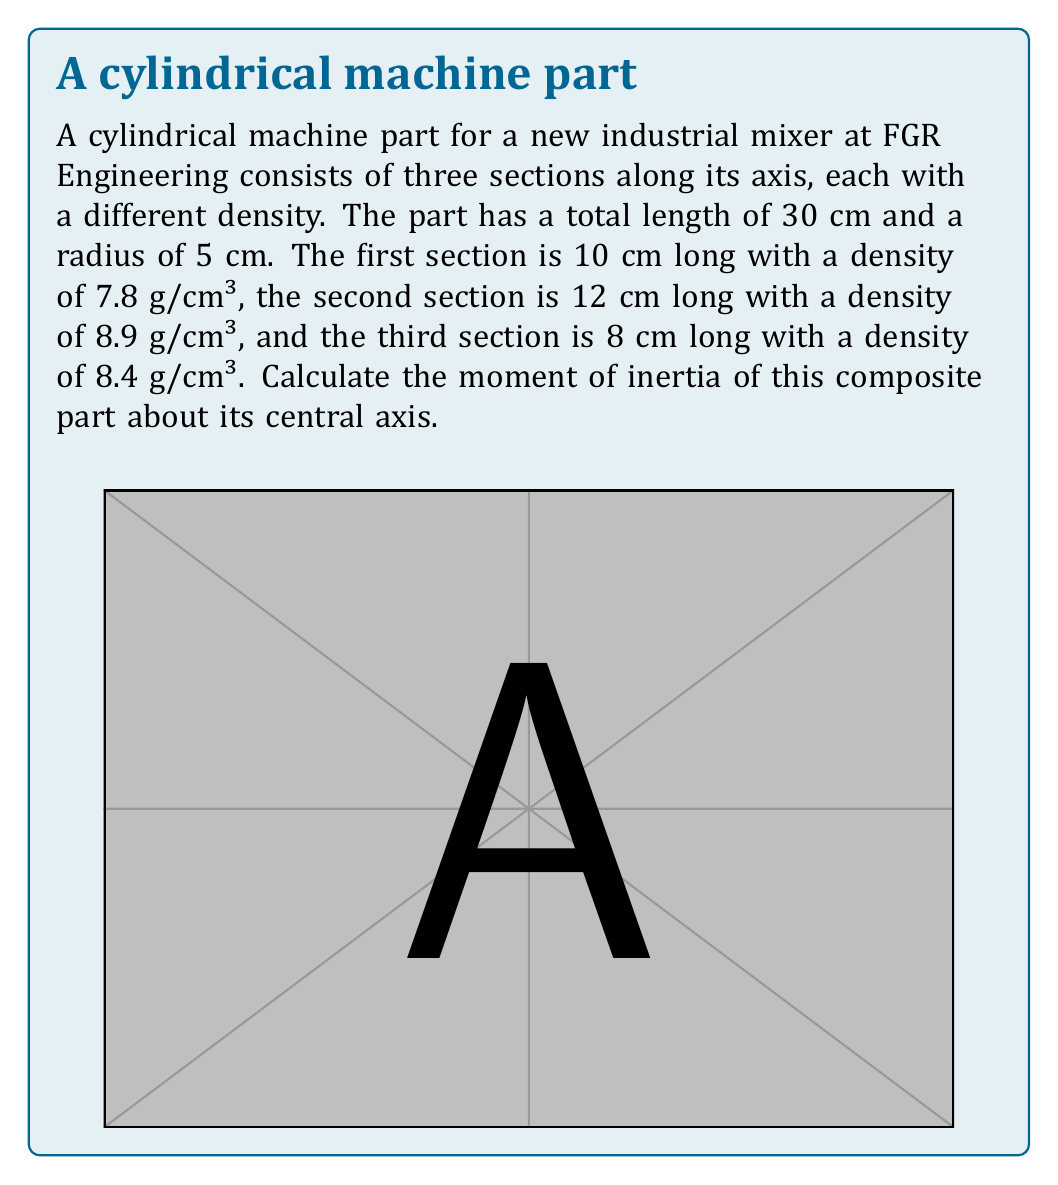Could you help me with this problem? To solve this problem, we need to calculate the moment of inertia for each section and then sum them up. The moment of inertia of a solid cylinder about its central axis is given by the formula:

$$I = \frac{1}{2}mr^2$$

where $m$ is the mass and $r$ is the radius.

Let's calculate the mass and moment of inertia for each section:

1. First section:
   Volume: $V_1 = \pi r^2 h_1 = \pi \cdot (5\text{ cm})^2 \cdot 10\text{ cm} = 785.4\text{ cm}^3$
   Mass: $m_1 = \rho_1 V_1 = 7.8\text{ g/cm}^3 \cdot 785.4\text{ cm}^3 = 6126.12\text{ g}$
   Moment of inertia: $I_1 = \frac{1}{2}m_1r^2 = \frac{1}{2} \cdot 6126.12\text{ g} \cdot (5\text{ cm})^2 = 76576.5\text{ g·cm}^2$

2. Second section:
   Volume: $V_2 = \pi r^2 h_2 = \pi \cdot (5\text{ cm})^2 \cdot 12\text{ cm} = 942.48\text{ cm}^3$
   Mass: $m_2 = \rho_2 V_2 = 8.9\text{ g/cm}^3 \cdot 942.48\text{ cm}^3 = 8388.072\text{ g}$
   Moment of inertia: $I_2 = \frac{1}{2}m_2r^2 = \frac{1}{2} \cdot 8388.072\text{ g} \cdot (5\text{ cm})^2 = 104850.9\text{ g·cm}^2$

3. Third section:
   Volume: $V_3 = \pi r^2 h_3 = \pi \cdot (5\text{ cm})^2 \cdot 8\text{ cm} = 628.32\text{ cm}^3$
   Mass: $m_3 = \rho_3 V_3 = 8.4\text{ g/cm}^3 \cdot 628.32\text{ cm}^3 = 5277.888\text{ g}$
   Moment of inertia: $I_3 = \frac{1}{2}m_3r^2 = \frac{1}{2} \cdot 5277.888\text{ g} \cdot (5\text{ cm})^2 = 65973.6\text{ g·cm}^2$

The total moment of inertia is the sum of the individual moments of inertia:

$$I_{\text{total}} = I_1 + I_2 + I_3 = 76576.5 + 104850.9 + 65973.6 = 247401\text{ g·cm}^2$$

Converting to kg·m²:
$$I_{\text{total}} = 247401\text{ g·cm}^2 \cdot \frac{1\text{ kg}}{1000\text{ g}} \cdot \left(\frac{1\text{ m}}{100\text{ cm}}\right)^2 = 0.0247401\text{ kg·m}^2$$
Answer: $0.0247401\text{ kg·m}^2$ 